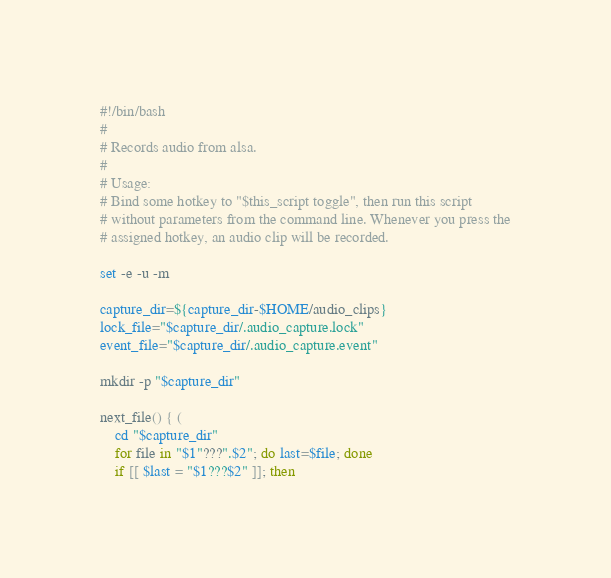<code> <loc_0><loc_0><loc_500><loc_500><_Bash_>#!/bin/bash
#
# Records audio from alsa.
#
# Usage:
# Bind some hotkey to "$this_script toggle", then run this script
# without parameters from the command line. Whenever you press the
# assigned hotkey, an audio clip will be recorded.

set -e -u -m

capture_dir=${capture_dir-$HOME/audio_clips}
lock_file="$capture_dir/.audio_capture.lock"
event_file="$capture_dir/.audio_capture.event"

mkdir -p "$capture_dir"

next_file() { (
    cd "$capture_dir"
    for file in "$1"???".$2"; do last=$file; done
    if [[ $last = "$1???$2" ]]; then</code> 